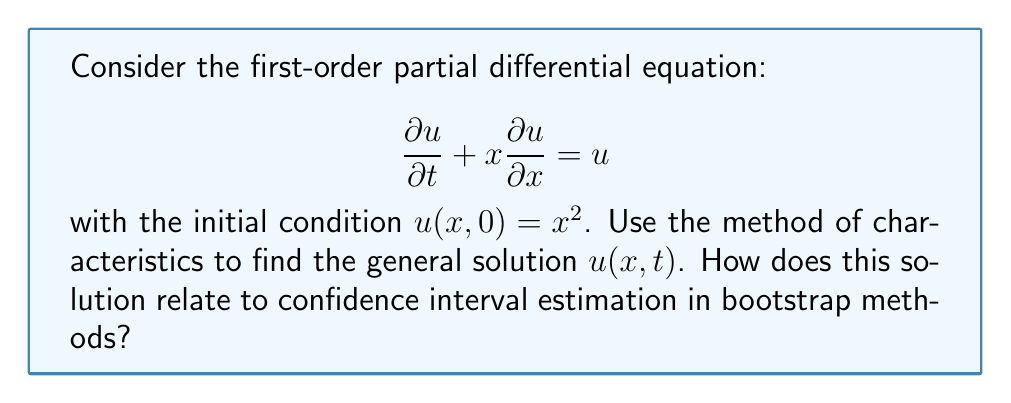Could you help me with this problem? Let's solve this PDE using the method of characteristics:

1) First, we write the characteristic equations:

   $$\frac{dt}{ds} = 1, \quad \frac{dx}{ds} = x, \quad \frac{du}{ds} = u$$

2) Solve for $t(s)$:
   $$t(s) = s + c_1$$

3) Solve for $x(s)$:
   $$\frac{dx}{ds} = x \implies \ln|x| = s + c_2 \implies x(s) = c_2e^s$$

4) Solve for $u(s)$:
   $$\frac{du}{ds} = u \implies \ln|u| = s + c_3 \implies u(s) = c_3e^s$$

5) From steps 3 and 4, we can write:
   $$u = cx, \quad \text{where } c = \frac{c_3}{c_2}$$

6) Now, use the initial condition $u(x,0) = x^2$:
   At $t=0$, $s=-c_1$, so $x = c_2e^{-c_1}$ and $u = c_3e^{-c_1}$
   Therefore, $c_3e^{-c_1} = (c_2e^{-c_1})^2 \implies c_3 = c_2^2$

7) The general solution is:
   $$u(x,t) = x \cdot \frac{c_3}{c_2} = x \cdot c_2 = xe^t$$

Relation to bootstrap confidence intervals:
This solution demonstrates exponential growth over time, which is analogous to how bootstrap resampling can lead to exponential growth in the number of possible resamples. In confidence interval estimation using bootstrap methods, we often deal with distributions that evolve over "resampling time", similar to how this PDE solution evolves over real time. The exponential nature of the solution also reflects the potential for rapid expansion of confidence intervals in certain bootstrap scenarios, especially when dealing with heavy-tailed distributions or small sample sizes.
Answer: $u(x,t) = xe^t$ 